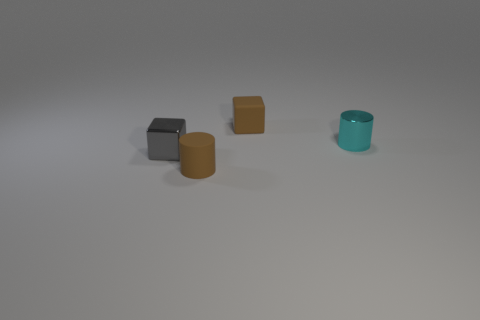What size is the object that is both to the right of the gray block and to the left of the rubber block?
Your response must be concise. Small. What number of other objects are the same shape as the small cyan object?
Ensure brevity in your answer.  1. How many cubes are yellow things or tiny gray shiny things?
Ensure brevity in your answer.  1. There is a small brown thing that is behind the cylinder to the right of the tiny matte cylinder; is there a small rubber cylinder behind it?
Ensure brevity in your answer.  No. The other thing that is the same shape as the cyan shiny object is what color?
Provide a short and direct response. Brown. How many yellow objects are either shiny cubes or large cubes?
Ensure brevity in your answer.  0. What material is the brown thing that is behind the brown matte object that is to the left of the tiny matte cube?
Your answer should be compact. Rubber. Does the cyan shiny object have the same shape as the tiny gray object?
Provide a succinct answer. No. There is another cylinder that is the same size as the cyan shiny cylinder; what color is it?
Provide a short and direct response. Brown. Is there a rubber cube that has the same color as the metal cylinder?
Keep it short and to the point. No. 